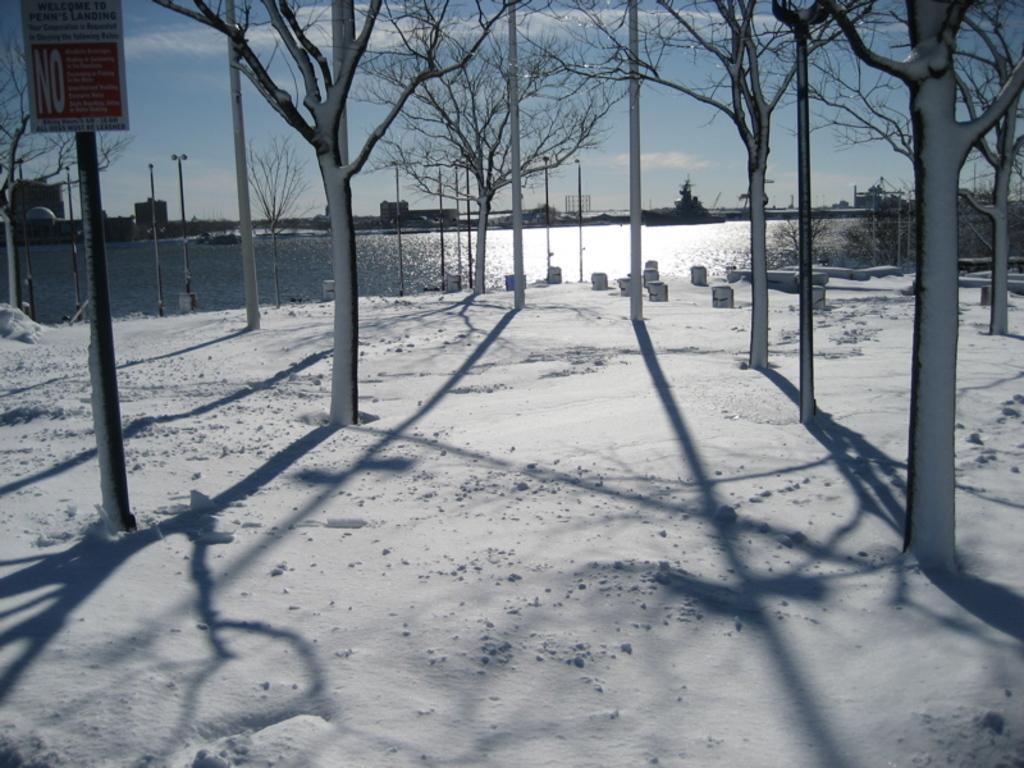Can you describe this image briefly? In this image we can see trees and land covered with snow. Background of the image sea is there. Left side of the image one sign board is present with pole. 